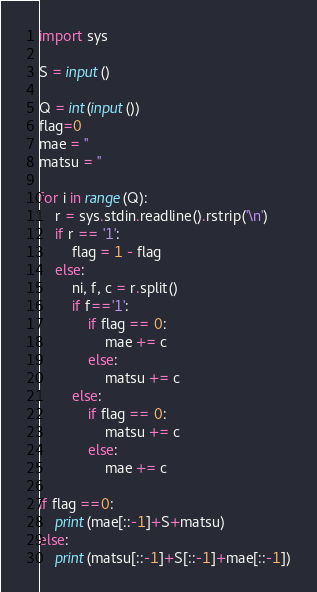<code> <loc_0><loc_0><loc_500><loc_500><_Python_>import sys

S = input()

Q = int(input())
flag=0
mae = ''
matsu = ''

for i in range(Q):
    r = sys.stdin.readline().rstrip('\n')
    if r == '1':
        flag = 1 - flag
    else:
        ni, f, c = r.split()
        if f=='1':
            if flag == 0:
                mae += c
            else:
                matsu += c
        else:
            if flag == 0:
                matsu += c
            else:
                mae += c

if flag ==0:
    print(mae[::-1]+S+matsu)
else:
    print(matsu[::-1]+S[::-1]+mae[::-1])</code> 